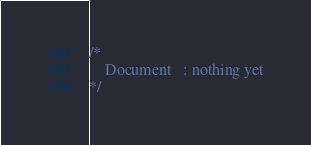Convert code to text. <code><loc_0><loc_0><loc_500><loc_500><_CSS_>/* 
    Document   : nothing yet
*/</code> 